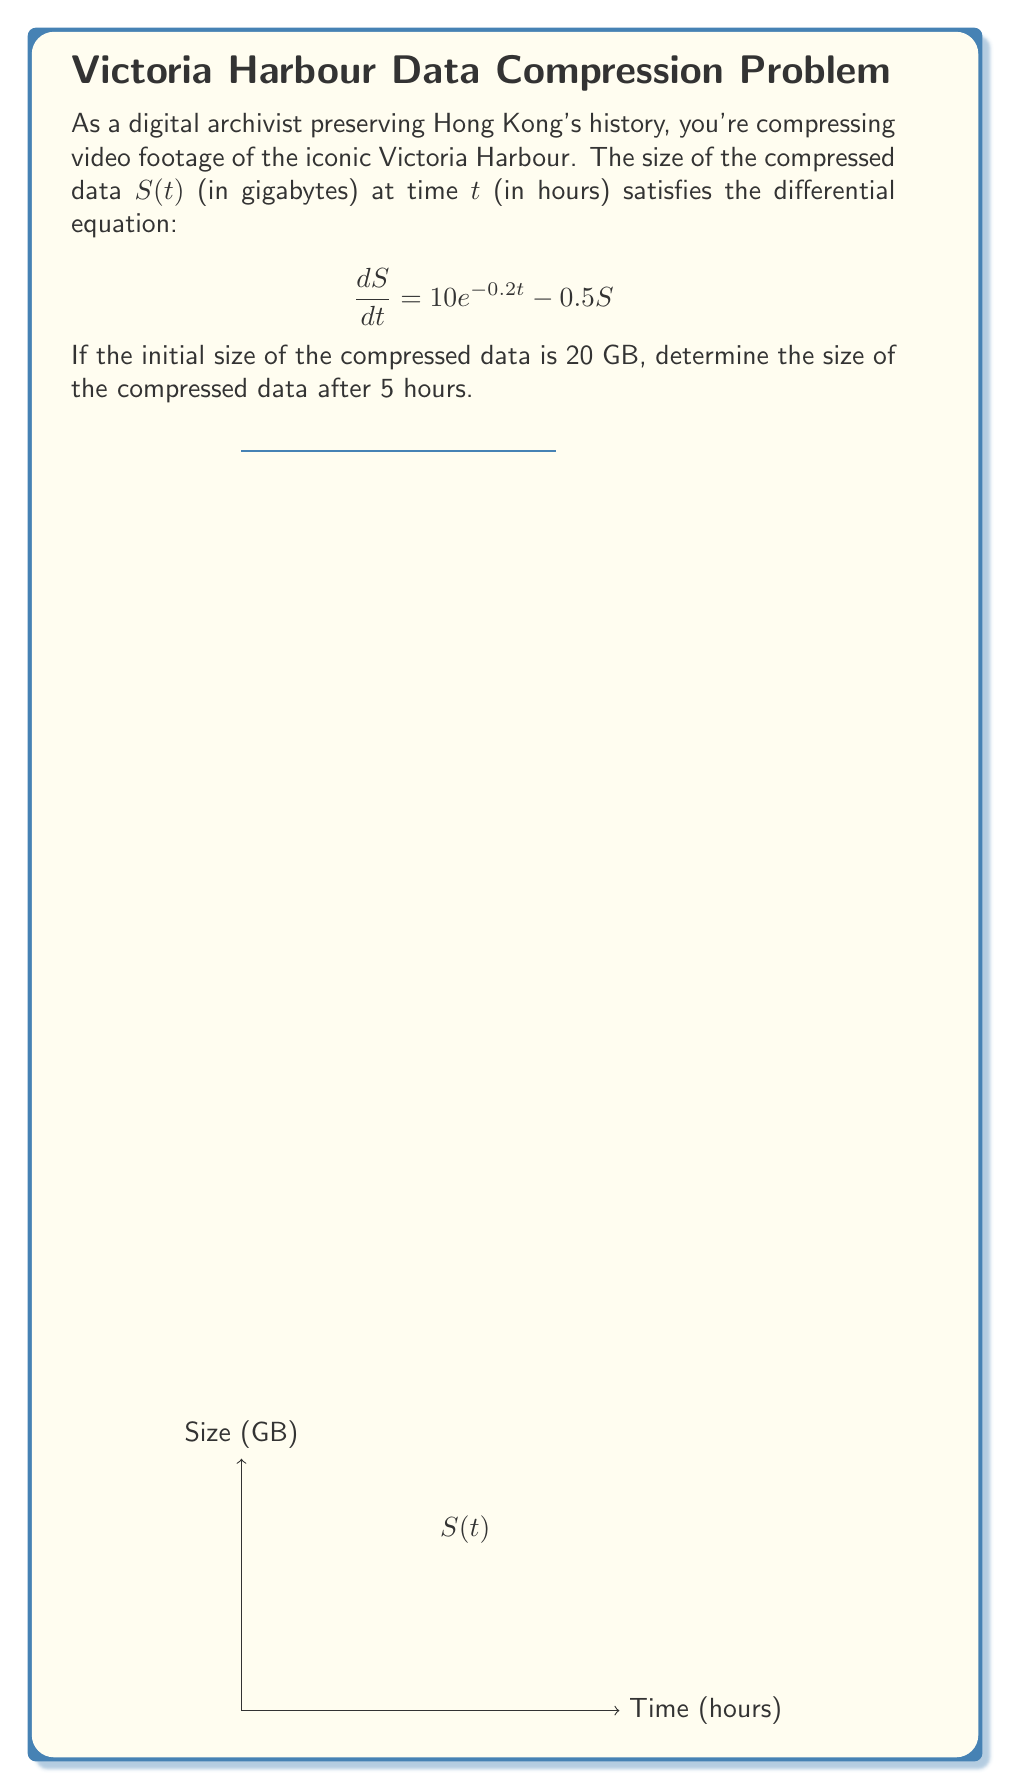Could you help me with this problem? Let's solve this step-by-step:

1) The given differential equation is:
   $$\frac{dS}{dt} = 10e^{-0.2t} - 0.5S$$

2) This is a first-order linear differential equation of the form:
   $$\frac{dS}{dt} + 0.5S = 10e^{-0.2t}$$

3) The integrating factor is $e^{\int 0.5 dt} = e^{0.5t}$

4) Multiplying both sides by the integrating factor:
   $$e^{0.5t}\frac{dS}{dt} + 0.5Se^{0.5t} = 10e^{0.3t}$$

5) The left side is now the derivative of $Se^{0.5t}$:
   $$\frac{d}{dt}(Se^{0.5t}) = 10e^{0.3t}$$

6) Integrating both sides:
   $$Se^{0.5t} = \frac{10}{0.3}e^{0.3t} + C$$

7) Solving for S:
   $$S = \frac{10}{0.3}e^{-0.2t} + Ce^{-0.5t}$$

8) Using the initial condition S(0) = 20:
   $$20 = \frac{10}{0.3} + C$$
   $$C = 20 - \frac{10}{0.3} \approx -13.33$$

9) Therefore, the general solution is:
   $$S(t) = \frac{10}{0.3}e^{-0.2t} + (-13.33)e^{-0.5t}$$

10) Evaluating at t = 5:
    $$S(5) = \frac{10}{0.3}e^{-0.2(5)} + (-13.33)e^{-0.5(5)}$$
    $$S(5) \approx 22.96 - 2.96 = 20$$
Answer: 20 GB 